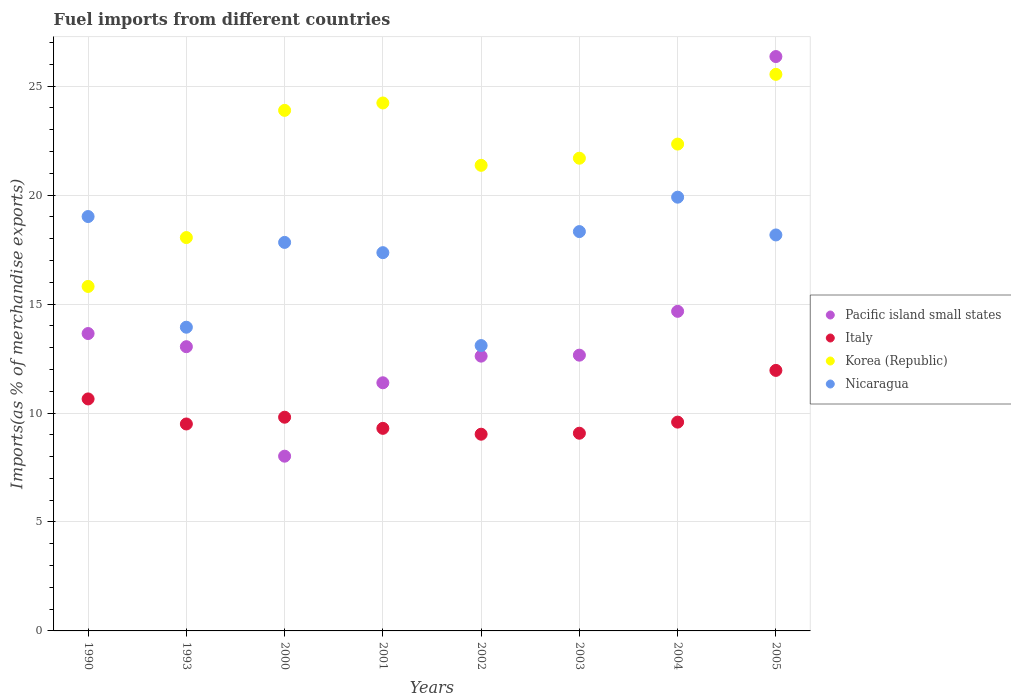How many different coloured dotlines are there?
Ensure brevity in your answer.  4. Is the number of dotlines equal to the number of legend labels?
Give a very brief answer. Yes. What is the percentage of imports to different countries in Korea (Republic) in 2005?
Your answer should be compact. 25.54. Across all years, what is the maximum percentage of imports to different countries in Pacific island small states?
Offer a terse response. 26.36. Across all years, what is the minimum percentage of imports to different countries in Pacific island small states?
Provide a succinct answer. 8.02. In which year was the percentage of imports to different countries in Nicaragua maximum?
Offer a terse response. 2004. What is the total percentage of imports to different countries in Italy in the graph?
Make the answer very short. 78.89. What is the difference between the percentage of imports to different countries in Nicaragua in 1993 and that in 2000?
Provide a succinct answer. -3.89. What is the difference between the percentage of imports to different countries in Nicaragua in 2000 and the percentage of imports to different countries in Italy in 1990?
Keep it short and to the point. 7.18. What is the average percentage of imports to different countries in Korea (Republic) per year?
Keep it short and to the point. 21.62. In the year 2000, what is the difference between the percentage of imports to different countries in Nicaragua and percentage of imports to different countries in Italy?
Ensure brevity in your answer.  8.02. In how many years, is the percentage of imports to different countries in Pacific island small states greater than 15 %?
Make the answer very short. 1. What is the ratio of the percentage of imports to different countries in Italy in 1990 to that in 2002?
Your answer should be very brief. 1.18. Is the difference between the percentage of imports to different countries in Nicaragua in 1993 and 2001 greater than the difference between the percentage of imports to different countries in Italy in 1993 and 2001?
Offer a very short reply. No. What is the difference between the highest and the second highest percentage of imports to different countries in Pacific island small states?
Your answer should be very brief. 11.69. What is the difference between the highest and the lowest percentage of imports to different countries in Nicaragua?
Ensure brevity in your answer.  6.81. In how many years, is the percentage of imports to different countries in Korea (Republic) greater than the average percentage of imports to different countries in Korea (Republic) taken over all years?
Offer a terse response. 5. Is it the case that in every year, the sum of the percentage of imports to different countries in Italy and percentage of imports to different countries in Pacific island small states  is greater than the sum of percentage of imports to different countries in Korea (Republic) and percentage of imports to different countries in Nicaragua?
Offer a terse response. No. Does the percentage of imports to different countries in Pacific island small states monotonically increase over the years?
Provide a succinct answer. No. Is the percentage of imports to different countries in Korea (Republic) strictly greater than the percentage of imports to different countries in Pacific island small states over the years?
Offer a very short reply. No. How many dotlines are there?
Offer a very short reply. 4. How many years are there in the graph?
Your answer should be compact. 8. Are the values on the major ticks of Y-axis written in scientific E-notation?
Your answer should be very brief. No. Does the graph contain grids?
Offer a terse response. Yes. Where does the legend appear in the graph?
Ensure brevity in your answer.  Center right. What is the title of the graph?
Your answer should be very brief. Fuel imports from different countries. What is the label or title of the X-axis?
Offer a very short reply. Years. What is the label or title of the Y-axis?
Keep it short and to the point. Imports(as % of merchandise exports). What is the Imports(as % of merchandise exports) of Pacific island small states in 1990?
Your response must be concise. 13.65. What is the Imports(as % of merchandise exports) in Italy in 1990?
Keep it short and to the point. 10.65. What is the Imports(as % of merchandise exports) in Korea (Republic) in 1990?
Provide a short and direct response. 15.81. What is the Imports(as % of merchandise exports) in Nicaragua in 1990?
Provide a short and direct response. 19.02. What is the Imports(as % of merchandise exports) in Pacific island small states in 1993?
Ensure brevity in your answer.  13.04. What is the Imports(as % of merchandise exports) of Italy in 1993?
Keep it short and to the point. 9.5. What is the Imports(as % of merchandise exports) in Korea (Republic) in 1993?
Give a very brief answer. 18.05. What is the Imports(as % of merchandise exports) of Nicaragua in 1993?
Your answer should be very brief. 13.94. What is the Imports(as % of merchandise exports) of Pacific island small states in 2000?
Provide a short and direct response. 8.02. What is the Imports(as % of merchandise exports) in Italy in 2000?
Offer a terse response. 9.81. What is the Imports(as % of merchandise exports) in Korea (Republic) in 2000?
Make the answer very short. 23.89. What is the Imports(as % of merchandise exports) of Nicaragua in 2000?
Ensure brevity in your answer.  17.83. What is the Imports(as % of merchandise exports) of Pacific island small states in 2001?
Ensure brevity in your answer.  11.39. What is the Imports(as % of merchandise exports) in Italy in 2001?
Provide a short and direct response. 9.3. What is the Imports(as % of merchandise exports) in Korea (Republic) in 2001?
Make the answer very short. 24.23. What is the Imports(as % of merchandise exports) of Nicaragua in 2001?
Ensure brevity in your answer.  17.36. What is the Imports(as % of merchandise exports) of Pacific island small states in 2002?
Your response must be concise. 12.61. What is the Imports(as % of merchandise exports) in Italy in 2002?
Your response must be concise. 9.03. What is the Imports(as % of merchandise exports) in Korea (Republic) in 2002?
Your answer should be compact. 21.37. What is the Imports(as % of merchandise exports) in Nicaragua in 2002?
Keep it short and to the point. 13.1. What is the Imports(as % of merchandise exports) in Pacific island small states in 2003?
Offer a terse response. 12.66. What is the Imports(as % of merchandise exports) in Italy in 2003?
Provide a succinct answer. 9.07. What is the Imports(as % of merchandise exports) of Korea (Republic) in 2003?
Your response must be concise. 21.69. What is the Imports(as % of merchandise exports) in Nicaragua in 2003?
Give a very brief answer. 18.33. What is the Imports(as % of merchandise exports) in Pacific island small states in 2004?
Offer a very short reply. 14.67. What is the Imports(as % of merchandise exports) of Italy in 2004?
Your response must be concise. 9.58. What is the Imports(as % of merchandise exports) of Korea (Republic) in 2004?
Keep it short and to the point. 22.34. What is the Imports(as % of merchandise exports) of Nicaragua in 2004?
Provide a short and direct response. 19.91. What is the Imports(as % of merchandise exports) in Pacific island small states in 2005?
Make the answer very short. 26.36. What is the Imports(as % of merchandise exports) of Italy in 2005?
Keep it short and to the point. 11.96. What is the Imports(as % of merchandise exports) of Korea (Republic) in 2005?
Provide a short and direct response. 25.54. What is the Imports(as % of merchandise exports) of Nicaragua in 2005?
Make the answer very short. 18.17. Across all years, what is the maximum Imports(as % of merchandise exports) in Pacific island small states?
Make the answer very short. 26.36. Across all years, what is the maximum Imports(as % of merchandise exports) of Italy?
Offer a very short reply. 11.96. Across all years, what is the maximum Imports(as % of merchandise exports) of Korea (Republic)?
Ensure brevity in your answer.  25.54. Across all years, what is the maximum Imports(as % of merchandise exports) in Nicaragua?
Provide a succinct answer. 19.91. Across all years, what is the minimum Imports(as % of merchandise exports) of Pacific island small states?
Keep it short and to the point. 8.02. Across all years, what is the minimum Imports(as % of merchandise exports) of Italy?
Make the answer very short. 9.03. Across all years, what is the minimum Imports(as % of merchandise exports) in Korea (Republic)?
Provide a succinct answer. 15.81. Across all years, what is the minimum Imports(as % of merchandise exports) of Nicaragua?
Your answer should be compact. 13.1. What is the total Imports(as % of merchandise exports) of Pacific island small states in the graph?
Your answer should be compact. 112.4. What is the total Imports(as % of merchandise exports) in Italy in the graph?
Keep it short and to the point. 78.89. What is the total Imports(as % of merchandise exports) of Korea (Republic) in the graph?
Ensure brevity in your answer.  172.93. What is the total Imports(as % of merchandise exports) in Nicaragua in the graph?
Keep it short and to the point. 137.65. What is the difference between the Imports(as % of merchandise exports) in Pacific island small states in 1990 and that in 1993?
Provide a succinct answer. 0.6. What is the difference between the Imports(as % of merchandise exports) of Italy in 1990 and that in 1993?
Your response must be concise. 1.15. What is the difference between the Imports(as % of merchandise exports) of Korea (Republic) in 1990 and that in 1993?
Your answer should be very brief. -2.24. What is the difference between the Imports(as % of merchandise exports) in Nicaragua in 1990 and that in 1993?
Offer a terse response. 5.08. What is the difference between the Imports(as % of merchandise exports) of Pacific island small states in 1990 and that in 2000?
Your answer should be very brief. 5.63. What is the difference between the Imports(as % of merchandise exports) of Italy in 1990 and that in 2000?
Offer a very short reply. 0.84. What is the difference between the Imports(as % of merchandise exports) of Korea (Republic) in 1990 and that in 2000?
Make the answer very short. -8.08. What is the difference between the Imports(as % of merchandise exports) of Nicaragua in 1990 and that in 2000?
Offer a terse response. 1.19. What is the difference between the Imports(as % of merchandise exports) of Pacific island small states in 1990 and that in 2001?
Offer a terse response. 2.26. What is the difference between the Imports(as % of merchandise exports) in Italy in 1990 and that in 2001?
Keep it short and to the point. 1.35. What is the difference between the Imports(as % of merchandise exports) in Korea (Republic) in 1990 and that in 2001?
Your answer should be compact. -8.42. What is the difference between the Imports(as % of merchandise exports) of Nicaragua in 1990 and that in 2001?
Give a very brief answer. 1.66. What is the difference between the Imports(as % of merchandise exports) in Pacific island small states in 1990 and that in 2002?
Make the answer very short. 1.04. What is the difference between the Imports(as % of merchandise exports) of Italy in 1990 and that in 2002?
Your answer should be very brief. 1.62. What is the difference between the Imports(as % of merchandise exports) in Korea (Republic) in 1990 and that in 2002?
Make the answer very short. -5.56. What is the difference between the Imports(as % of merchandise exports) of Nicaragua in 1990 and that in 2002?
Your answer should be very brief. 5.92. What is the difference between the Imports(as % of merchandise exports) in Italy in 1990 and that in 2003?
Give a very brief answer. 1.57. What is the difference between the Imports(as % of merchandise exports) of Korea (Republic) in 1990 and that in 2003?
Ensure brevity in your answer.  -5.88. What is the difference between the Imports(as % of merchandise exports) in Nicaragua in 1990 and that in 2003?
Provide a short and direct response. 0.69. What is the difference between the Imports(as % of merchandise exports) of Pacific island small states in 1990 and that in 2004?
Keep it short and to the point. -1.02. What is the difference between the Imports(as % of merchandise exports) of Italy in 1990 and that in 2004?
Keep it short and to the point. 1.06. What is the difference between the Imports(as % of merchandise exports) of Korea (Republic) in 1990 and that in 2004?
Ensure brevity in your answer.  -6.53. What is the difference between the Imports(as % of merchandise exports) in Nicaragua in 1990 and that in 2004?
Keep it short and to the point. -0.89. What is the difference between the Imports(as % of merchandise exports) in Pacific island small states in 1990 and that in 2005?
Give a very brief answer. -12.71. What is the difference between the Imports(as % of merchandise exports) in Italy in 1990 and that in 2005?
Provide a short and direct response. -1.31. What is the difference between the Imports(as % of merchandise exports) of Korea (Republic) in 1990 and that in 2005?
Your answer should be compact. -9.73. What is the difference between the Imports(as % of merchandise exports) of Nicaragua in 1990 and that in 2005?
Make the answer very short. 0.84. What is the difference between the Imports(as % of merchandise exports) of Pacific island small states in 1993 and that in 2000?
Provide a succinct answer. 5.03. What is the difference between the Imports(as % of merchandise exports) in Italy in 1993 and that in 2000?
Offer a very short reply. -0.31. What is the difference between the Imports(as % of merchandise exports) in Korea (Republic) in 1993 and that in 2000?
Provide a succinct answer. -5.84. What is the difference between the Imports(as % of merchandise exports) in Nicaragua in 1993 and that in 2000?
Give a very brief answer. -3.89. What is the difference between the Imports(as % of merchandise exports) of Pacific island small states in 1993 and that in 2001?
Ensure brevity in your answer.  1.66. What is the difference between the Imports(as % of merchandise exports) of Italy in 1993 and that in 2001?
Your answer should be compact. 0.2. What is the difference between the Imports(as % of merchandise exports) in Korea (Republic) in 1993 and that in 2001?
Offer a terse response. -6.18. What is the difference between the Imports(as % of merchandise exports) in Nicaragua in 1993 and that in 2001?
Ensure brevity in your answer.  -3.42. What is the difference between the Imports(as % of merchandise exports) of Pacific island small states in 1993 and that in 2002?
Make the answer very short. 0.43. What is the difference between the Imports(as % of merchandise exports) in Italy in 1993 and that in 2002?
Offer a terse response. 0.47. What is the difference between the Imports(as % of merchandise exports) in Korea (Republic) in 1993 and that in 2002?
Ensure brevity in your answer.  -3.32. What is the difference between the Imports(as % of merchandise exports) in Nicaragua in 1993 and that in 2002?
Offer a very short reply. 0.84. What is the difference between the Imports(as % of merchandise exports) in Pacific island small states in 1993 and that in 2003?
Give a very brief answer. 0.39. What is the difference between the Imports(as % of merchandise exports) of Italy in 1993 and that in 2003?
Ensure brevity in your answer.  0.42. What is the difference between the Imports(as % of merchandise exports) of Korea (Republic) in 1993 and that in 2003?
Give a very brief answer. -3.64. What is the difference between the Imports(as % of merchandise exports) of Nicaragua in 1993 and that in 2003?
Offer a terse response. -4.39. What is the difference between the Imports(as % of merchandise exports) of Pacific island small states in 1993 and that in 2004?
Offer a terse response. -1.62. What is the difference between the Imports(as % of merchandise exports) in Italy in 1993 and that in 2004?
Your response must be concise. -0.09. What is the difference between the Imports(as % of merchandise exports) of Korea (Republic) in 1993 and that in 2004?
Provide a succinct answer. -4.29. What is the difference between the Imports(as % of merchandise exports) in Nicaragua in 1993 and that in 2004?
Your answer should be very brief. -5.97. What is the difference between the Imports(as % of merchandise exports) of Pacific island small states in 1993 and that in 2005?
Ensure brevity in your answer.  -13.32. What is the difference between the Imports(as % of merchandise exports) in Italy in 1993 and that in 2005?
Your response must be concise. -2.46. What is the difference between the Imports(as % of merchandise exports) of Korea (Republic) in 1993 and that in 2005?
Ensure brevity in your answer.  -7.49. What is the difference between the Imports(as % of merchandise exports) of Nicaragua in 1993 and that in 2005?
Ensure brevity in your answer.  -4.24. What is the difference between the Imports(as % of merchandise exports) of Pacific island small states in 2000 and that in 2001?
Ensure brevity in your answer.  -3.37. What is the difference between the Imports(as % of merchandise exports) in Italy in 2000 and that in 2001?
Provide a succinct answer. 0.51. What is the difference between the Imports(as % of merchandise exports) of Korea (Republic) in 2000 and that in 2001?
Provide a succinct answer. -0.34. What is the difference between the Imports(as % of merchandise exports) of Nicaragua in 2000 and that in 2001?
Your answer should be compact. 0.47. What is the difference between the Imports(as % of merchandise exports) in Pacific island small states in 2000 and that in 2002?
Your response must be concise. -4.59. What is the difference between the Imports(as % of merchandise exports) of Italy in 2000 and that in 2002?
Offer a terse response. 0.78. What is the difference between the Imports(as % of merchandise exports) of Korea (Republic) in 2000 and that in 2002?
Offer a very short reply. 2.52. What is the difference between the Imports(as % of merchandise exports) in Nicaragua in 2000 and that in 2002?
Your answer should be compact. 4.73. What is the difference between the Imports(as % of merchandise exports) of Pacific island small states in 2000 and that in 2003?
Make the answer very short. -4.64. What is the difference between the Imports(as % of merchandise exports) of Italy in 2000 and that in 2003?
Your response must be concise. 0.74. What is the difference between the Imports(as % of merchandise exports) in Korea (Republic) in 2000 and that in 2003?
Your answer should be compact. 2.2. What is the difference between the Imports(as % of merchandise exports) in Nicaragua in 2000 and that in 2003?
Give a very brief answer. -0.5. What is the difference between the Imports(as % of merchandise exports) in Pacific island small states in 2000 and that in 2004?
Provide a short and direct response. -6.65. What is the difference between the Imports(as % of merchandise exports) in Italy in 2000 and that in 2004?
Provide a succinct answer. 0.23. What is the difference between the Imports(as % of merchandise exports) of Korea (Republic) in 2000 and that in 2004?
Ensure brevity in your answer.  1.55. What is the difference between the Imports(as % of merchandise exports) in Nicaragua in 2000 and that in 2004?
Your response must be concise. -2.08. What is the difference between the Imports(as % of merchandise exports) in Pacific island small states in 2000 and that in 2005?
Offer a very short reply. -18.34. What is the difference between the Imports(as % of merchandise exports) of Italy in 2000 and that in 2005?
Your answer should be compact. -2.15. What is the difference between the Imports(as % of merchandise exports) in Korea (Republic) in 2000 and that in 2005?
Ensure brevity in your answer.  -1.65. What is the difference between the Imports(as % of merchandise exports) of Nicaragua in 2000 and that in 2005?
Provide a succinct answer. -0.34. What is the difference between the Imports(as % of merchandise exports) in Pacific island small states in 2001 and that in 2002?
Your answer should be compact. -1.22. What is the difference between the Imports(as % of merchandise exports) in Italy in 2001 and that in 2002?
Make the answer very short. 0.27. What is the difference between the Imports(as % of merchandise exports) in Korea (Republic) in 2001 and that in 2002?
Your answer should be very brief. 2.86. What is the difference between the Imports(as % of merchandise exports) in Nicaragua in 2001 and that in 2002?
Give a very brief answer. 4.26. What is the difference between the Imports(as % of merchandise exports) in Pacific island small states in 2001 and that in 2003?
Provide a short and direct response. -1.27. What is the difference between the Imports(as % of merchandise exports) in Italy in 2001 and that in 2003?
Offer a very short reply. 0.22. What is the difference between the Imports(as % of merchandise exports) of Korea (Republic) in 2001 and that in 2003?
Offer a terse response. 2.54. What is the difference between the Imports(as % of merchandise exports) of Nicaragua in 2001 and that in 2003?
Provide a short and direct response. -0.97. What is the difference between the Imports(as % of merchandise exports) in Pacific island small states in 2001 and that in 2004?
Your answer should be very brief. -3.28. What is the difference between the Imports(as % of merchandise exports) in Italy in 2001 and that in 2004?
Give a very brief answer. -0.29. What is the difference between the Imports(as % of merchandise exports) in Korea (Republic) in 2001 and that in 2004?
Keep it short and to the point. 1.89. What is the difference between the Imports(as % of merchandise exports) in Nicaragua in 2001 and that in 2004?
Ensure brevity in your answer.  -2.55. What is the difference between the Imports(as % of merchandise exports) of Pacific island small states in 2001 and that in 2005?
Keep it short and to the point. -14.97. What is the difference between the Imports(as % of merchandise exports) in Italy in 2001 and that in 2005?
Keep it short and to the point. -2.66. What is the difference between the Imports(as % of merchandise exports) in Korea (Republic) in 2001 and that in 2005?
Provide a succinct answer. -1.31. What is the difference between the Imports(as % of merchandise exports) in Nicaragua in 2001 and that in 2005?
Provide a short and direct response. -0.81. What is the difference between the Imports(as % of merchandise exports) in Pacific island small states in 2002 and that in 2003?
Give a very brief answer. -0.04. What is the difference between the Imports(as % of merchandise exports) of Italy in 2002 and that in 2003?
Give a very brief answer. -0.04. What is the difference between the Imports(as % of merchandise exports) in Korea (Republic) in 2002 and that in 2003?
Keep it short and to the point. -0.33. What is the difference between the Imports(as % of merchandise exports) in Nicaragua in 2002 and that in 2003?
Provide a short and direct response. -5.23. What is the difference between the Imports(as % of merchandise exports) in Pacific island small states in 2002 and that in 2004?
Provide a succinct answer. -2.06. What is the difference between the Imports(as % of merchandise exports) of Italy in 2002 and that in 2004?
Make the answer very short. -0.55. What is the difference between the Imports(as % of merchandise exports) of Korea (Republic) in 2002 and that in 2004?
Your response must be concise. -0.97. What is the difference between the Imports(as % of merchandise exports) in Nicaragua in 2002 and that in 2004?
Offer a terse response. -6.81. What is the difference between the Imports(as % of merchandise exports) of Pacific island small states in 2002 and that in 2005?
Your response must be concise. -13.75. What is the difference between the Imports(as % of merchandise exports) of Italy in 2002 and that in 2005?
Ensure brevity in your answer.  -2.93. What is the difference between the Imports(as % of merchandise exports) in Korea (Republic) in 2002 and that in 2005?
Your answer should be compact. -4.17. What is the difference between the Imports(as % of merchandise exports) of Nicaragua in 2002 and that in 2005?
Make the answer very short. -5.08. What is the difference between the Imports(as % of merchandise exports) in Pacific island small states in 2003 and that in 2004?
Your response must be concise. -2.01. What is the difference between the Imports(as % of merchandise exports) in Italy in 2003 and that in 2004?
Offer a terse response. -0.51. What is the difference between the Imports(as % of merchandise exports) of Korea (Republic) in 2003 and that in 2004?
Offer a very short reply. -0.65. What is the difference between the Imports(as % of merchandise exports) in Nicaragua in 2003 and that in 2004?
Offer a very short reply. -1.58. What is the difference between the Imports(as % of merchandise exports) of Pacific island small states in 2003 and that in 2005?
Provide a short and direct response. -13.7. What is the difference between the Imports(as % of merchandise exports) in Italy in 2003 and that in 2005?
Make the answer very short. -2.88. What is the difference between the Imports(as % of merchandise exports) of Korea (Republic) in 2003 and that in 2005?
Make the answer very short. -3.85. What is the difference between the Imports(as % of merchandise exports) of Nicaragua in 2003 and that in 2005?
Your answer should be compact. 0.15. What is the difference between the Imports(as % of merchandise exports) in Pacific island small states in 2004 and that in 2005?
Ensure brevity in your answer.  -11.69. What is the difference between the Imports(as % of merchandise exports) of Italy in 2004 and that in 2005?
Your response must be concise. -2.37. What is the difference between the Imports(as % of merchandise exports) of Korea (Republic) in 2004 and that in 2005?
Offer a terse response. -3.2. What is the difference between the Imports(as % of merchandise exports) in Nicaragua in 2004 and that in 2005?
Your answer should be very brief. 1.73. What is the difference between the Imports(as % of merchandise exports) in Pacific island small states in 1990 and the Imports(as % of merchandise exports) in Italy in 1993?
Make the answer very short. 4.15. What is the difference between the Imports(as % of merchandise exports) in Pacific island small states in 1990 and the Imports(as % of merchandise exports) in Korea (Republic) in 1993?
Your answer should be very brief. -4.4. What is the difference between the Imports(as % of merchandise exports) in Pacific island small states in 1990 and the Imports(as % of merchandise exports) in Nicaragua in 1993?
Keep it short and to the point. -0.29. What is the difference between the Imports(as % of merchandise exports) of Italy in 1990 and the Imports(as % of merchandise exports) of Korea (Republic) in 1993?
Your response must be concise. -7.41. What is the difference between the Imports(as % of merchandise exports) of Italy in 1990 and the Imports(as % of merchandise exports) of Nicaragua in 1993?
Provide a short and direct response. -3.29. What is the difference between the Imports(as % of merchandise exports) of Korea (Republic) in 1990 and the Imports(as % of merchandise exports) of Nicaragua in 1993?
Provide a short and direct response. 1.87. What is the difference between the Imports(as % of merchandise exports) in Pacific island small states in 1990 and the Imports(as % of merchandise exports) in Italy in 2000?
Offer a very short reply. 3.84. What is the difference between the Imports(as % of merchandise exports) of Pacific island small states in 1990 and the Imports(as % of merchandise exports) of Korea (Republic) in 2000?
Offer a very short reply. -10.24. What is the difference between the Imports(as % of merchandise exports) in Pacific island small states in 1990 and the Imports(as % of merchandise exports) in Nicaragua in 2000?
Keep it short and to the point. -4.18. What is the difference between the Imports(as % of merchandise exports) in Italy in 1990 and the Imports(as % of merchandise exports) in Korea (Republic) in 2000?
Offer a very short reply. -13.24. What is the difference between the Imports(as % of merchandise exports) in Italy in 1990 and the Imports(as % of merchandise exports) in Nicaragua in 2000?
Provide a succinct answer. -7.18. What is the difference between the Imports(as % of merchandise exports) of Korea (Republic) in 1990 and the Imports(as % of merchandise exports) of Nicaragua in 2000?
Your answer should be compact. -2.02. What is the difference between the Imports(as % of merchandise exports) in Pacific island small states in 1990 and the Imports(as % of merchandise exports) in Italy in 2001?
Make the answer very short. 4.35. What is the difference between the Imports(as % of merchandise exports) of Pacific island small states in 1990 and the Imports(as % of merchandise exports) of Korea (Republic) in 2001?
Your answer should be compact. -10.58. What is the difference between the Imports(as % of merchandise exports) in Pacific island small states in 1990 and the Imports(as % of merchandise exports) in Nicaragua in 2001?
Your answer should be very brief. -3.71. What is the difference between the Imports(as % of merchandise exports) in Italy in 1990 and the Imports(as % of merchandise exports) in Korea (Republic) in 2001?
Provide a short and direct response. -13.58. What is the difference between the Imports(as % of merchandise exports) in Italy in 1990 and the Imports(as % of merchandise exports) in Nicaragua in 2001?
Provide a succinct answer. -6.71. What is the difference between the Imports(as % of merchandise exports) of Korea (Republic) in 1990 and the Imports(as % of merchandise exports) of Nicaragua in 2001?
Your response must be concise. -1.55. What is the difference between the Imports(as % of merchandise exports) of Pacific island small states in 1990 and the Imports(as % of merchandise exports) of Italy in 2002?
Give a very brief answer. 4.62. What is the difference between the Imports(as % of merchandise exports) in Pacific island small states in 1990 and the Imports(as % of merchandise exports) in Korea (Republic) in 2002?
Ensure brevity in your answer.  -7.72. What is the difference between the Imports(as % of merchandise exports) of Pacific island small states in 1990 and the Imports(as % of merchandise exports) of Nicaragua in 2002?
Ensure brevity in your answer.  0.55. What is the difference between the Imports(as % of merchandise exports) in Italy in 1990 and the Imports(as % of merchandise exports) in Korea (Republic) in 2002?
Offer a very short reply. -10.72. What is the difference between the Imports(as % of merchandise exports) of Italy in 1990 and the Imports(as % of merchandise exports) of Nicaragua in 2002?
Offer a terse response. -2.45. What is the difference between the Imports(as % of merchandise exports) of Korea (Republic) in 1990 and the Imports(as % of merchandise exports) of Nicaragua in 2002?
Your response must be concise. 2.71. What is the difference between the Imports(as % of merchandise exports) in Pacific island small states in 1990 and the Imports(as % of merchandise exports) in Italy in 2003?
Give a very brief answer. 4.58. What is the difference between the Imports(as % of merchandise exports) in Pacific island small states in 1990 and the Imports(as % of merchandise exports) in Korea (Republic) in 2003?
Offer a very short reply. -8.05. What is the difference between the Imports(as % of merchandise exports) in Pacific island small states in 1990 and the Imports(as % of merchandise exports) in Nicaragua in 2003?
Offer a very short reply. -4.68. What is the difference between the Imports(as % of merchandise exports) in Italy in 1990 and the Imports(as % of merchandise exports) in Korea (Republic) in 2003?
Offer a very short reply. -11.05. What is the difference between the Imports(as % of merchandise exports) of Italy in 1990 and the Imports(as % of merchandise exports) of Nicaragua in 2003?
Make the answer very short. -7.68. What is the difference between the Imports(as % of merchandise exports) in Korea (Republic) in 1990 and the Imports(as % of merchandise exports) in Nicaragua in 2003?
Give a very brief answer. -2.52. What is the difference between the Imports(as % of merchandise exports) of Pacific island small states in 1990 and the Imports(as % of merchandise exports) of Italy in 2004?
Make the answer very short. 4.07. What is the difference between the Imports(as % of merchandise exports) in Pacific island small states in 1990 and the Imports(as % of merchandise exports) in Korea (Republic) in 2004?
Your answer should be very brief. -8.69. What is the difference between the Imports(as % of merchandise exports) of Pacific island small states in 1990 and the Imports(as % of merchandise exports) of Nicaragua in 2004?
Keep it short and to the point. -6.26. What is the difference between the Imports(as % of merchandise exports) in Italy in 1990 and the Imports(as % of merchandise exports) in Korea (Republic) in 2004?
Make the answer very short. -11.7. What is the difference between the Imports(as % of merchandise exports) of Italy in 1990 and the Imports(as % of merchandise exports) of Nicaragua in 2004?
Your response must be concise. -9.26. What is the difference between the Imports(as % of merchandise exports) of Korea (Republic) in 1990 and the Imports(as % of merchandise exports) of Nicaragua in 2004?
Your answer should be very brief. -4.1. What is the difference between the Imports(as % of merchandise exports) of Pacific island small states in 1990 and the Imports(as % of merchandise exports) of Italy in 2005?
Give a very brief answer. 1.69. What is the difference between the Imports(as % of merchandise exports) of Pacific island small states in 1990 and the Imports(as % of merchandise exports) of Korea (Republic) in 2005?
Provide a succinct answer. -11.89. What is the difference between the Imports(as % of merchandise exports) in Pacific island small states in 1990 and the Imports(as % of merchandise exports) in Nicaragua in 2005?
Give a very brief answer. -4.53. What is the difference between the Imports(as % of merchandise exports) in Italy in 1990 and the Imports(as % of merchandise exports) in Korea (Republic) in 2005?
Provide a short and direct response. -14.9. What is the difference between the Imports(as % of merchandise exports) in Italy in 1990 and the Imports(as % of merchandise exports) in Nicaragua in 2005?
Your response must be concise. -7.53. What is the difference between the Imports(as % of merchandise exports) in Korea (Republic) in 1990 and the Imports(as % of merchandise exports) in Nicaragua in 2005?
Your answer should be very brief. -2.36. What is the difference between the Imports(as % of merchandise exports) of Pacific island small states in 1993 and the Imports(as % of merchandise exports) of Italy in 2000?
Provide a short and direct response. 3.24. What is the difference between the Imports(as % of merchandise exports) in Pacific island small states in 1993 and the Imports(as % of merchandise exports) in Korea (Republic) in 2000?
Make the answer very short. -10.85. What is the difference between the Imports(as % of merchandise exports) in Pacific island small states in 1993 and the Imports(as % of merchandise exports) in Nicaragua in 2000?
Give a very brief answer. -4.79. What is the difference between the Imports(as % of merchandise exports) of Italy in 1993 and the Imports(as % of merchandise exports) of Korea (Republic) in 2000?
Your answer should be very brief. -14.39. What is the difference between the Imports(as % of merchandise exports) of Italy in 1993 and the Imports(as % of merchandise exports) of Nicaragua in 2000?
Provide a succinct answer. -8.33. What is the difference between the Imports(as % of merchandise exports) of Korea (Republic) in 1993 and the Imports(as % of merchandise exports) of Nicaragua in 2000?
Ensure brevity in your answer.  0.22. What is the difference between the Imports(as % of merchandise exports) of Pacific island small states in 1993 and the Imports(as % of merchandise exports) of Italy in 2001?
Make the answer very short. 3.75. What is the difference between the Imports(as % of merchandise exports) in Pacific island small states in 1993 and the Imports(as % of merchandise exports) in Korea (Republic) in 2001?
Offer a terse response. -11.19. What is the difference between the Imports(as % of merchandise exports) in Pacific island small states in 1993 and the Imports(as % of merchandise exports) in Nicaragua in 2001?
Your answer should be very brief. -4.32. What is the difference between the Imports(as % of merchandise exports) in Italy in 1993 and the Imports(as % of merchandise exports) in Korea (Republic) in 2001?
Offer a very short reply. -14.73. What is the difference between the Imports(as % of merchandise exports) of Italy in 1993 and the Imports(as % of merchandise exports) of Nicaragua in 2001?
Offer a terse response. -7.86. What is the difference between the Imports(as % of merchandise exports) in Korea (Republic) in 1993 and the Imports(as % of merchandise exports) in Nicaragua in 2001?
Offer a very short reply. 0.69. What is the difference between the Imports(as % of merchandise exports) in Pacific island small states in 1993 and the Imports(as % of merchandise exports) in Italy in 2002?
Your answer should be compact. 4.02. What is the difference between the Imports(as % of merchandise exports) in Pacific island small states in 1993 and the Imports(as % of merchandise exports) in Korea (Republic) in 2002?
Your response must be concise. -8.32. What is the difference between the Imports(as % of merchandise exports) of Pacific island small states in 1993 and the Imports(as % of merchandise exports) of Nicaragua in 2002?
Provide a succinct answer. -0.05. What is the difference between the Imports(as % of merchandise exports) in Italy in 1993 and the Imports(as % of merchandise exports) in Korea (Republic) in 2002?
Offer a terse response. -11.87. What is the difference between the Imports(as % of merchandise exports) in Italy in 1993 and the Imports(as % of merchandise exports) in Nicaragua in 2002?
Make the answer very short. -3.6. What is the difference between the Imports(as % of merchandise exports) of Korea (Republic) in 1993 and the Imports(as % of merchandise exports) of Nicaragua in 2002?
Your answer should be very brief. 4.96. What is the difference between the Imports(as % of merchandise exports) of Pacific island small states in 1993 and the Imports(as % of merchandise exports) of Italy in 2003?
Offer a very short reply. 3.97. What is the difference between the Imports(as % of merchandise exports) in Pacific island small states in 1993 and the Imports(as % of merchandise exports) in Korea (Republic) in 2003?
Your answer should be compact. -8.65. What is the difference between the Imports(as % of merchandise exports) in Pacific island small states in 1993 and the Imports(as % of merchandise exports) in Nicaragua in 2003?
Provide a succinct answer. -5.28. What is the difference between the Imports(as % of merchandise exports) of Italy in 1993 and the Imports(as % of merchandise exports) of Korea (Republic) in 2003?
Make the answer very short. -12.2. What is the difference between the Imports(as % of merchandise exports) of Italy in 1993 and the Imports(as % of merchandise exports) of Nicaragua in 2003?
Your response must be concise. -8.83. What is the difference between the Imports(as % of merchandise exports) of Korea (Republic) in 1993 and the Imports(as % of merchandise exports) of Nicaragua in 2003?
Make the answer very short. -0.27. What is the difference between the Imports(as % of merchandise exports) of Pacific island small states in 1993 and the Imports(as % of merchandise exports) of Italy in 2004?
Give a very brief answer. 3.46. What is the difference between the Imports(as % of merchandise exports) in Pacific island small states in 1993 and the Imports(as % of merchandise exports) in Korea (Republic) in 2004?
Your answer should be very brief. -9.3. What is the difference between the Imports(as % of merchandise exports) in Pacific island small states in 1993 and the Imports(as % of merchandise exports) in Nicaragua in 2004?
Your response must be concise. -6.86. What is the difference between the Imports(as % of merchandise exports) of Italy in 1993 and the Imports(as % of merchandise exports) of Korea (Republic) in 2004?
Your answer should be compact. -12.85. What is the difference between the Imports(as % of merchandise exports) of Italy in 1993 and the Imports(as % of merchandise exports) of Nicaragua in 2004?
Keep it short and to the point. -10.41. What is the difference between the Imports(as % of merchandise exports) of Korea (Republic) in 1993 and the Imports(as % of merchandise exports) of Nicaragua in 2004?
Provide a succinct answer. -1.85. What is the difference between the Imports(as % of merchandise exports) in Pacific island small states in 1993 and the Imports(as % of merchandise exports) in Italy in 2005?
Your answer should be compact. 1.09. What is the difference between the Imports(as % of merchandise exports) of Pacific island small states in 1993 and the Imports(as % of merchandise exports) of Korea (Republic) in 2005?
Provide a short and direct response. -12.5. What is the difference between the Imports(as % of merchandise exports) of Pacific island small states in 1993 and the Imports(as % of merchandise exports) of Nicaragua in 2005?
Provide a succinct answer. -5.13. What is the difference between the Imports(as % of merchandise exports) in Italy in 1993 and the Imports(as % of merchandise exports) in Korea (Republic) in 2005?
Provide a succinct answer. -16.05. What is the difference between the Imports(as % of merchandise exports) of Italy in 1993 and the Imports(as % of merchandise exports) of Nicaragua in 2005?
Ensure brevity in your answer.  -8.68. What is the difference between the Imports(as % of merchandise exports) in Korea (Republic) in 1993 and the Imports(as % of merchandise exports) in Nicaragua in 2005?
Make the answer very short. -0.12. What is the difference between the Imports(as % of merchandise exports) in Pacific island small states in 2000 and the Imports(as % of merchandise exports) in Italy in 2001?
Offer a terse response. -1.28. What is the difference between the Imports(as % of merchandise exports) in Pacific island small states in 2000 and the Imports(as % of merchandise exports) in Korea (Republic) in 2001?
Ensure brevity in your answer.  -16.21. What is the difference between the Imports(as % of merchandise exports) of Pacific island small states in 2000 and the Imports(as % of merchandise exports) of Nicaragua in 2001?
Provide a succinct answer. -9.34. What is the difference between the Imports(as % of merchandise exports) of Italy in 2000 and the Imports(as % of merchandise exports) of Korea (Republic) in 2001?
Your response must be concise. -14.42. What is the difference between the Imports(as % of merchandise exports) of Italy in 2000 and the Imports(as % of merchandise exports) of Nicaragua in 2001?
Your answer should be very brief. -7.55. What is the difference between the Imports(as % of merchandise exports) in Korea (Republic) in 2000 and the Imports(as % of merchandise exports) in Nicaragua in 2001?
Ensure brevity in your answer.  6.53. What is the difference between the Imports(as % of merchandise exports) in Pacific island small states in 2000 and the Imports(as % of merchandise exports) in Italy in 2002?
Offer a very short reply. -1.01. What is the difference between the Imports(as % of merchandise exports) in Pacific island small states in 2000 and the Imports(as % of merchandise exports) in Korea (Republic) in 2002?
Keep it short and to the point. -13.35. What is the difference between the Imports(as % of merchandise exports) in Pacific island small states in 2000 and the Imports(as % of merchandise exports) in Nicaragua in 2002?
Offer a terse response. -5.08. What is the difference between the Imports(as % of merchandise exports) in Italy in 2000 and the Imports(as % of merchandise exports) in Korea (Republic) in 2002?
Your response must be concise. -11.56. What is the difference between the Imports(as % of merchandise exports) in Italy in 2000 and the Imports(as % of merchandise exports) in Nicaragua in 2002?
Provide a succinct answer. -3.29. What is the difference between the Imports(as % of merchandise exports) of Korea (Republic) in 2000 and the Imports(as % of merchandise exports) of Nicaragua in 2002?
Offer a very short reply. 10.79. What is the difference between the Imports(as % of merchandise exports) in Pacific island small states in 2000 and the Imports(as % of merchandise exports) in Italy in 2003?
Provide a succinct answer. -1.05. What is the difference between the Imports(as % of merchandise exports) in Pacific island small states in 2000 and the Imports(as % of merchandise exports) in Korea (Republic) in 2003?
Provide a succinct answer. -13.68. What is the difference between the Imports(as % of merchandise exports) in Pacific island small states in 2000 and the Imports(as % of merchandise exports) in Nicaragua in 2003?
Offer a terse response. -10.31. What is the difference between the Imports(as % of merchandise exports) of Italy in 2000 and the Imports(as % of merchandise exports) of Korea (Republic) in 2003?
Your answer should be very brief. -11.89. What is the difference between the Imports(as % of merchandise exports) of Italy in 2000 and the Imports(as % of merchandise exports) of Nicaragua in 2003?
Make the answer very short. -8.52. What is the difference between the Imports(as % of merchandise exports) in Korea (Republic) in 2000 and the Imports(as % of merchandise exports) in Nicaragua in 2003?
Your answer should be very brief. 5.56. What is the difference between the Imports(as % of merchandise exports) of Pacific island small states in 2000 and the Imports(as % of merchandise exports) of Italy in 2004?
Give a very brief answer. -1.56. What is the difference between the Imports(as % of merchandise exports) in Pacific island small states in 2000 and the Imports(as % of merchandise exports) in Korea (Republic) in 2004?
Your response must be concise. -14.32. What is the difference between the Imports(as % of merchandise exports) in Pacific island small states in 2000 and the Imports(as % of merchandise exports) in Nicaragua in 2004?
Your answer should be very brief. -11.89. What is the difference between the Imports(as % of merchandise exports) in Italy in 2000 and the Imports(as % of merchandise exports) in Korea (Republic) in 2004?
Provide a short and direct response. -12.54. What is the difference between the Imports(as % of merchandise exports) of Italy in 2000 and the Imports(as % of merchandise exports) of Nicaragua in 2004?
Your answer should be compact. -10.1. What is the difference between the Imports(as % of merchandise exports) of Korea (Republic) in 2000 and the Imports(as % of merchandise exports) of Nicaragua in 2004?
Your answer should be compact. 3.98. What is the difference between the Imports(as % of merchandise exports) of Pacific island small states in 2000 and the Imports(as % of merchandise exports) of Italy in 2005?
Provide a short and direct response. -3.94. What is the difference between the Imports(as % of merchandise exports) of Pacific island small states in 2000 and the Imports(as % of merchandise exports) of Korea (Republic) in 2005?
Make the answer very short. -17.52. What is the difference between the Imports(as % of merchandise exports) in Pacific island small states in 2000 and the Imports(as % of merchandise exports) in Nicaragua in 2005?
Keep it short and to the point. -10.15. What is the difference between the Imports(as % of merchandise exports) in Italy in 2000 and the Imports(as % of merchandise exports) in Korea (Republic) in 2005?
Provide a short and direct response. -15.74. What is the difference between the Imports(as % of merchandise exports) in Italy in 2000 and the Imports(as % of merchandise exports) in Nicaragua in 2005?
Your answer should be very brief. -8.37. What is the difference between the Imports(as % of merchandise exports) of Korea (Republic) in 2000 and the Imports(as % of merchandise exports) of Nicaragua in 2005?
Provide a succinct answer. 5.72. What is the difference between the Imports(as % of merchandise exports) of Pacific island small states in 2001 and the Imports(as % of merchandise exports) of Italy in 2002?
Your answer should be very brief. 2.36. What is the difference between the Imports(as % of merchandise exports) in Pacific island small states in 2001 and the Imports(as % of merchandise exports) in Korea (Republic) in 2002?
Offer a very short reply. -9.98. What is the difference between the Imports(as % of merchandise exports) of Pacific island small states in 2001 and the Imports(as % of merchandise exports) of Nicaragua in 2002?
Keep it short and to the point. -1.71. What is the difference between the Imports(as % of merchandise exports) of Italy in 2001 and the Imports(as % of merchandise exports) of Korea (Republic) in 2002?
Your answer should be very brief. -12.07. What is the difference between the Imports(as % of merchandise exports) of Italy in 2001 and the Imports(as % of merchandise exports) of Nicaragua in 2002?
Make the answer very short. -3.8. What is the difference between the Imports(as % of merchandise exports) of Korea (Republic) in 2001 and the Imports(as % of merchandise exports) of Nicaragua in 2002?
Provide a succinct answer. 11.13. What is the difference between the Imports(as % of merchandise exports) of Pacific island small states in 2001 and the Imports(as % of merchandise exports) of Italy in 2003?
Give a very brief answer. 2.32. What is the difference between the Imports(as % of merchandise exports) of Pacific island small states in 2001 and the Imports(as % of merchandise exports) of Korea (Republic) in 2003?
Keep it short and to the point. -10.31. What is the difference between the Imports(as % of merchandise exports) in Pacific island small states in 2001 and the Imports(as % of merchandise exports) in Nicaragua in 2003?
Your answer should be very brief. -6.94. What is the difference between the Imports(as % of merchandise exports) of Italy in 2001 and the Imports(as % of merchandise exports) of Korea (Republic) in 2003?
Make the answer very short. -12.4. What is the difference between the Imports(as % of merchandise exports) in Italy in 2001 and the Imports(as % of merchandise exports) in Nicaragua in 2003?
Your answer should be compact. -9.03. What is the difference between the Imports(as % of merchandise exports) of Korea (Republic) in 2001 and the Imports(as % of merchandise exports) of Nicaragua in 2003?
Give a very brief answer. 5.9. What is the difference between the Imports(as % of merchandise exports) of Pacific island small states in 2001 and the Imports(as % of merchandise exports) of Italy in 2004?
Offer a very short reply. 1.81. What is the difference between the Imports(as % of merchandise exports) in Pacific island small states in 2001 and the Imports(as % of merchandise exports) in Korea (Republic) in 2004?
Your response must be concise. -10.95. What is the difference between the Imports(as % of merchandise exports) in Pacific island small states in 2001 and the Imports(as % of merchandise exports) in Nicaragua in 2004?
Give a very brief answer. -8.52. What is the difference between the Imports(as % of merchandise exports) in Italy in 2001 and the Imports(as % of merchandise exports) in Korea (Republic) in 2004?
Provide a short and direct response. -13.05. What is the difference between the Imports(as % of merchandise exports) in Italy in 2001 and the Imports(as % of merchandise exports) in Nicaragua in 2004?
Offer a terse response. -10.61. What is the difference between the Imports(as % of merchandise exports) in Korea (Republic) in 2001 and the Imports(as % of merchandise exports) in Nicaragua in 2004?
Provide a short and direct response. 4.32. What is the difference between the Imports(as % of merchandise exports) of Pacific island small states in 2001 and the Imports(as % of merchandise exports) of Italy in 2005?
Provide a short and direct response. -0.57. What is the difference between the Imports(as % of merchandise exports) in Pacific island small states in 2001 and the Imports(as % of merchandise exports) in Korea (Republic) in 2005?
Offer a terse response. -14.15. What is the difference between the Imports(as % of merchandise exports) in Pacific island small states in 2001 and the Imports(as % of merchandise exports) in Nicaragua in 2005?
Make the answer very short. -6.78. What is the difference between the Imports(as % of merchandise exports) in Italy in 2001 and the Imports(as % of merchandise exports) in Korea (Republic) in 2005?
Give a very brief answer. -16.25. What is the difference between the Imports(as % of merchandise exports) in Italy in 2001 and the Imports(as % of merchandise exports) in Nicaragua in 2005?
Keep it short and to the point. -8.88. What is the difference between the Imports(as % of merchandise exports) in Korea (Republic) in 2001 and the Imports(as % of merchandise exports) in Nicaragua in 2005?
Your answer should be compact. 6.06. What is the difference between the Imports(as % of merchandise exports) in Pacific island small states in 2002 and the Imports(as % of merchandise exports) in Italy in 2003?
Offer a very short reply. 3.54. What is the difference between the Imports(as % of merchandise exports) of Pacific island small states in 2002 and the Imports(as % of merchandise exports) of Korea (Republic) in 2003?
Offer a terse response. -9.08. What is the difference between the Imports(as % of merchandise exports) of Pacific island small states in 2002 and the Imports(as % of merchandise exports) of Nicaragua in 2003?
Make the answer very short. -5.72. What is the difference between the Imports(as % of merchandise exports) in Italy in 2002 and the Imports(as % of merchandise exports) in Korea (Republic) in 2003?
Keep it short and to the point. -12.67. What is the difference between the Imports(as % of merchandise exports) of Italy in 2002 and the Imports(as % of merchandise exports) of Nicaragua in 2003?
Keep it short and to the point. -9.3. What is the difference between the Imports(as % of merchandise exports) in Korea (Republic) in 2002 and the Imports(as % of merchandise exports) in Nicaragua in 2003?
Your response must be concise. 3.04. What is the difference between the Imports(as % of merchandise exports) in Pacific island small states in 2002 and the Imports(as % of merchandise exports) in Italy in 2004?
Provide a succinct answer. 3.03. What is the difference between the Imports(as % of merchandise exports) of Pacific island small states in 2002 and the Imports(as % of merchandise exports) of Korea (Republic) in 2004?
Your answer should be compact. -9.73. What is the difference between the Imports(as % of merchandise exports) in Pacific island small states in 2002 and the Imports(as % of merchandise exports) in Nicaragua in 2004?
Offer a very short reply. -7.3. What is the difference between the Imports(as % of merchandise exports) in Italy in 2002 and the Imports(as % of merchandise exports) in Korea (Republic) in 2004?
Give a very brief answer. -13.32. What is the difference between the Imports(as % of merchandise exports) in Italy in 2002 and the Imports(as % of merchandise exports) in Nicaragua in 2004?
Your answer should be compact. -10.88. What is the difference between the Imports(as % of merchandise exports) in Korea (Republic) in 2002 and the Imports(as % of merchandise exports) in Nicaragua in 2004?
Offer a very short reply. 1.46. What is the difference between the Imports(as % of merchandise exports) of Pacific island small states in 2002 and the Imports(as % of merchandise exports) of Italy in 2005?
Your answer should be compact. 0.65. What is the difference between the Imports(as % of merchandise exports) of Pacific island small states in 2002 and the Imports(as % of merchandise exports) of Korea (Republic) in 2005?
Offer a terse response. -12.93. What is the difference between the Imports(as % of merchandise exports) of Pacific island small states in 2002 and the Imports(as % of merchandise exports) of Nicaragua in 2005?
Ensure brevity in your answer.  -5.56. What is the difference between the Imports(as % of merchandise exports) in Italy in 2002 and the Imports(as % of merchandise exports) in Korea (Republic) in 2005?
Provide a short and direct response. -16.52. What is the difference between the Imports(as % of merchandise exports) of Italy in 2002 and the Imports(as % of merchandise exports) of Nicaragua in 2005?
Your answer should be very brief. -9.15. What is the difference between the Imports(as % of merchandise exports) of Korea (Republic) in 2002 and the Imports(as % of merchandise exports) of Nicaragua in 2005?
Your answer should be compact. 3.2. What is the difference between the Imports(as % of merchandise exports) in Pacific island small states in 2003 and the Imports(as % of merchandise exports) in Italy in 2004?
Keep it short and to the point. 3.07. What is the difference between the Imports(as % of merchandise exports) of Pacific island small states in 2003 and the Imports(as % of merchandise exports) of Korea (Republic) in 2004?
Ensure brevity in your answer.  -9.69. What is the difference between the Imports(as % of merchandise exports) of Pacific island small states in 2003 and the Imports(as % of merchandise exports) of Nicaragua in 2004?
Offer a very short reply. -7.25. What is the difference between the Imports(as % of merchandise exports) of Italy in 2003 and the Imports(as % of merchandise exports) of Korea (Republic) in 2004?
Your response must be concise. -13.27. What is the difference between the Imports(as % of merchandise exports) in Italy in 2003 and the Imports(as % of merchandise exports) in Nicaragua in 2004?
Offer a very short reply. -10.83. What is the difference between the Imports(as % of merchandise exports) in Korea (Republic) in 2003 and the Imports(as % of merchandise exports) in Nicaragua in 2004?
Make the answer very short. 1.79. What is the difference between the Imports(as % of merchandise exports) of Pacific island small states in 2003 and the Imports(as % of merchandise exports) of Italy in 2005?
Make the answer very short. 0.7. What is the difference between the Imports(as % of merchandise exports) of Pacific island small states in 2003 and the Imports(as % of merchandise exports) of Korea (Republic) in 2005?
Your response must be concise. -12.89. What is the difference between the Imports(as % of merchandise exports) of Pacific island small states in 2003 and the Imports(as % of merchandise exports) of Nicaragua in 2005?
Provide a short and direct response. -5.52. What is the difference between the Imports(as % of merchandise exports) in Italy in 2003 and the Imports(as % of merchandise exports) in Korea (Republic) in 2005?
Offer a very short reply. -16.47. What is the difference between the Imports(as % of merchandise exports) in Italy in 2003 and the Imports(as % of merchandise exports) in Nicaragua in 2005?
Your answer should be very brief. -9.1. What is the difference between the Imports(as % of merchandise exports) in Korea (Republic) in 2003 and the Imports(as % of merchandise exports) in Nicaragua in 2005?
Keep it short and to the point. 3.52. What is the difference between the Imports(as % of merchandise exports) of Pacific island small states in 2004 and the Imports(as % of merchandise exports) of Italy in 2005?
Your answer should be very brief. 2.71. What is the difference between the Imports(as % of merchandise exports) of Pacific island small states in 2004 and the Imports(as % of merchandise exports) of Korea (Republic) in 2005?
Ensure brevity in your answer.  -10.88. What is the difference between the Imports(as % of merchandise exports) of Pacific island small states in 2004 and the Imports(as % of merchandise exports) of Nicaragua in 2005?
Make the answer very short. -3.51. What is the difference between the Imports(as % of merchandise exports) in Italy in 2004 and the Imports(as % of merchandise exports) in Korea (Republic) in 2005?
Your answer should be very brief. -15.96. What is the difference between the Imports(as % of merchandise exports) of Italy in 2004 and the Imports(as % of merchandise exports) of Nicaragua in 2005?
Make the answer very short. -8.59. What is the difference between the Imports(as % of merchandise exports) in Korea (Republic) in 2004 and the Imports(as % of merchandise exports) in Nicaragua in 2005?
Make the answer very short. 4.17. What is the average Imports(as % of merchandise exports) in Pacific island small states per year?
Give a very brief answer. 14.05. What is the average Imports(as % of merchandise exports) in Italy per year?
Keep it short and to the point. 9.86. What is the average Imports(as % of merchandise exports) of Korea (Republic) per year?
Offer a terse response. 21.62. What is the average Imports(as % of merchandise exports) of Nicaragua per year?
Offer a very short reply. 17.21. In the year 1990, what is the difference between the Imports(as % of merchandise exports) of Pacific island small states and Imports(as % of merchandise exports) of Italy?
Your answer should be compact. 3. In the year 1990, what is the difference between the Imports(as % of merchandise exports) of Pacific island small states and Imports(as % of merchandise exports) of Korea (Republic)?
Provide a succinct answer. -2.16. In the year 1990, what is the difference between the Imports(as % of merchandise exports) in Pacific island small states and Imports(as % of merchandise exports) in Nicaragua?
Keep it short and to the point. -5.37. In the year 1990, what is the difference between the Imports(as % of merchandise exports) in Italy and Imports(as % of merchandise exports) in Korea (Republic)?
Provide a succinct answer. -5.16. In the year 1990, what is the difference between the Imports(as % of merchandise exports) of Italy and Imports(as % of merchandise exports) of Nicaragua?
Your answer should be compact. -8.37. In the year 1990, what is the difference between the Imports(as % of merchandise exports) in Korea (Republic) and Imports(as % of merchandise exports) in Nicaragua?
Provide a succinct answer. -3.21. In the year 1993, what is the difference between the Imports(as % of merchandise exports) in Pacific island small states and Imports(as % of merchandise exports) in Italy?
Make the answer very short. 3.55. In the year 1993, what is the difference between the Imports(as % of merchandise exports) in Pacific island small states and Imports(as % of merchandise exports) in Korea (Republic)?
Provide a succinct answer. -5.01. In the year 1993, what is the difference between the Imports(as % of merchandise exports) in Pacific island small states and Imports(as % of merchandise exports) in Nicaragua?
Provide a succinct answer. -0.89. In the year 1993, what is the difference between the Imports(as % of merchandise exports) in Italy and Imports(as % of merchandise exports) in Korea (Republic)?
Provide a succinct answer. -8.56. In the year 1993, what is the difference between the Imports(as % of merchandise exports) of Italy and Imports(as % of merchandise exports) of Nicaragua?
Provide a succinct answer. -4.44. In the year 1993, what is the difference between the Imports(as % of merchandise exports) in Korea (Republic) and Imports(as % of merchandise exports) in Nicaragua?
Your response must be concise. 4.11. In the year 2000, what is the difference between the Imports(as % of merchandise exports) in Pacific island small states and Imports(as % of merchandise exports) in Italy?
Your answer should be compact. -1.79. In the year 2000, what is the difference between the Imports(as % of merchandise exports) in Pacific island small states and Imports(as % of merchandise exports) in Korea (Republic)?
Provide a short and direct response. -15.87. In the year 2000, what is the difference between the Imports(as % of merchandise exports) of Pacific island small states and Imports(as % of merchandise exports) of Nicaragua?
Offer a very short reply. -9.81. In the year 2000, what is the difference between the Imports(as % of merchandise exports) of Italy and Imports(as % of merchandise exports) of Korea (Republic)?
Keep it short and to the point. -14.08. In the year 2000, what is the difference between the Imports(as % of merchandise exports) of Italy and Imports(as % of merchandise exports) of Nicaragua?
Give a very brief answer. -8.02. In the year 2000, what is the difference between the Imports(as % of merchandise exports) in Korea (Republic) and Imports(as % of merchandise exports) in Nicaragua?
Your answer should be very brief. 6.06. In the year 2001, what is the difference between the Imports(as % of merchandise exports) in Pacific island small states and Imports(as % of merchandise exports) in Italy?
Provide a short and direct response. 2.09. In the year 2001, what is the difference between the Imports(as % of merchandise exports) in Pacific island small states and Imports(as % of merchandise exports) in Korea (Republic)?
Your answer should be very brief. -12.84. In the year 2001, what is the difference between the Imports(as % of merchandise exports) of Pacific island small states and Imports(as % of merchandise exports) of Nicaragua?
Your answer should be very brief. -5.97. In the year 2001, what is the difference between the Imports(as % of merchandise exports) of Italy and Imports(as % of merchandise exports) of Korea (Republic)?
Provide a succinct answer. -14.93. In the year 2001, what is the difference between the Imports(as % of merchandise exports) in Italy and Imports(as % of merchandise exports) in Nicaragua?
Your answer should be compact. -8.06. In the year 2001, what is the difference between the Imports(as % of merchandise exports) of Korea (Republic) and Imports(as % of merchandise exports) of Nicaragua?
Offer a terse response. 6.87. In the year 2002, what is the difference between the Imports(as % of merchandise exports) of Pacific island small states and Imports(as % of merchandise exports) of Italy?
Make the answer very short. 3.58. In the year 2002, what is the difference between the Imports(as % of merchandise exports) in Pacific island small states and Imports(as % of merchandise exports) in Korea (Republic)?
Make the answer very short. -8.76. In the year 2002, what is the difference between the Imports(as % of merchandise exports) of Pacific island small states and Imports(as % of merchandise exports) of Nicaragua?
Your response must be concise. -0.49. In the year 2002, what is the difference between the Imports(as % of merchandise exports) in Italy and Imports(as % of merchandise exports) in Korea (Republic)?
Keep it short and to the point. -12.34. In the year 2002, what is the difference between the Imports(as % of merchandise exports) in Italy and Imports(as % of merchandise exports) in Nicaragua?
Give a very brief answer. -4.07. In the year 2002, what is the difference between the Imports(as % of merchandise exports) in Korea (Republic) and Imports(as % of merchandise exports) in Nicaragua?
Offer a terse response. 8.27. In the year 2003, what is the difference between the Imports(as % of merchandise exports) in Pacific island small states and Imports(as % of merchandise exports) in Italy?
Provide a short and direct response. 3.58. In the year 2003, what is the difference between the Imports(as % of merchandise exports) in Pacific island small states and Imports(as % of merchandise exports) in Korea (Republic)?
Make the answer very short. -9.04. In the year 2003, what is the difference between the Imports(as % of merchandise exports) of Pacific island small states and Imports(as % of merchandise exports) of Nicaragua?
Provide a succinct answer. -5.67. In the year 2003, what is the difference between the Imports(as % of merchandise exports) in Italy and Imports(as % of merchandise exports) in Korea (Republic)?
Make the answer very short. -12.62. In the year 2003, what is the difference between the Imports(as % of merchandise exports) of Italy and Imports(as % of merchandise exports) of Nicaragua?
Offer a very short reply. -9.25. In the year 2003, what is the difference between the Imports(as % of merchandise exports) of Korea (Republic) and Imports(as % of merchandise exports) of Nicaragua?
Make the answer very short. 3.37. In the year 2004, what is the difference between the Imports(as % of merchandise exports) in Pacific island small states and Imports(as % of merchandise exports) in Italy?
Provide a succinct answer. 5.08. In the year 2004, what is the difference between the Imports(as % of merchandise exports) in Pacific island small states and Imports(as % of merchandise exports) in Korea (Republic)?
Your answer should be very brief. -7.68. In the year 2004, what is the difference between the Imports(as % of merchandise exports) of Pacific island small states and Imports(as % of merchandise exports) of Nicaragua?
Your response must be concise. -5.24. In the year 2004, what is the difference between the Imports(as % of merchandise exports) in Italy and Imports(as % of merchandise exports) in Korea (Republic)?
Give a very brief answer. -12.76. In the year 2004, what is the difference between the Imports(as % of merchandise exports) of Italy and Imports(as % of merchandise exports) of Nicaragua?
Provide a short and direct response. -10.32. In the year 2004, what is the difference between the Imports(as % of merchandise exports) in Korea (Republic) and Imports(as % of merchandise exports) in Nicaragua?
Your answer should be very brief. 2.44. In the year 2005, what is the difference between the Imports(as % of merchandise exports) in Pacific island small states and Imports(as % of merchandise exports) in Italy?
Your response must be concise. 14.4. In the year 2005, what is the difference between the Imports(as % of merchandise exports) of Pacific island small states and Imports(as % of merchandise exports) of Korea (Republic)?
Offer a very short reply. 0.82. In the year 2005, what is the difference between the Imports(as % of merchandise exports) of Pacific island small states and Imports(as % of merchandise exports) of Nicaragua?
Offer a very short reply. 8.19. In the year 2005, what is the difference between the Imports(as % of merchandise exports) of Italy and Imports(as % of merchandise exports) of Korea (Republic)?
Your answer should be compact. -13.59. In the year 2005, what is the difference between the Imports(as % of merchandise exports) in Italy and Imports(as % of merchandise exports) in Nicaragua?
Ensure brevity in your answer.  -6.22. In the year 2005, what is the difference between the Imports(as % of merchandise exports) of Korea (Republic) and Imports(as % of merchandise exports) of Nicaragua?
Make the answer very short. 7.37. What is the ratio of the Imports(as % of merchandise exports) of Pacific island small states in 1990 to that in 1993?
Offer a terse response. 1.05. What is the ratio of the Imports(as % of merchandise exports) of Italy in 1990 to that in 1993?
Provide a succinct answer. 1.12. What is the ratio of the Imports(as % of merchandise exports) in Korea (Republic) in 1990 to that in 1993?
Your answer should be compact. 0.88. What is the ratio of the Imports(as % of merchandise exports) of Nicaragua in 1990 to that in 1993?
Provide a short and direct response. 1.36. What is the ratio of the Imports(as % of merchandise exports) of Pacific island small states in 1990 to that in 2000?
Your answer should be compact. 1.7. What is the ratio of the Imports(as % of merchandise exports) in Italy in 1990 to that in 2000?
Make the answer very short. 1.09. What is the ratio of the Imports(as % of merchandise exports) of Korea (Republic) in 1990 to that in 2000?
Provide a short and direct response. 0.66. What is the ratio of the Imports(as % of merchandise exports) of Nicaragua in 1990 to that in 2000?
Offer a terse response. 1.07. What is the ratio of the Imports(as % of merchandise exports) in Pacific island small states in 1990 to that in 2001?
Make the answer very short. 1.2. What is the ratio of the Imports(as % of merchandise exports) in Italy in 1990 to that in 2001?
Provide a succinct answer. 1.15. What is the ratio of the Imports(as % of merchandise exports) of Korea (Republic) in 1990 to that in 2001?
Offer a terse response. 0.65. What is the ratio of the Imports(as % of merchandise exports) in Nicaragua in 1990 to that in 2001?
Your answer should be compact. 1.1. What is the ratio of the Imports(as % of merchandise exports) of Pacific island small states in 1990 to that in 2002?
Your answer should be very brief. 1.08. What is the ratio of the Imports(as % of merchandise exports) of Italy in 1990 to that in 2002?
Your answer should be compact. 1.18. What is the ratio of the Imports(as % of merchandise exports) of Korea (Republic) in 1990 to that in 2002?
Provide a succinct answer. 0.74. What is the ratio of the Imports(as % of merchandise exports) of Nicaragua in 1990 to that in 2002?
Your response must be concise. 1.45. What is the ratio of the Imports(as % of merchandise exports) of Pacific island small states in 1990 to that in 2003?
Your answer should be very brief. 1.08. What is the ratio of the Imports(as % of merchandise exports) of Italy in 1990 to that in 2003?
Give a very brief answer. 1.17. What is the ratio of the Imports(as % of merchandise exports) of Korea (Republic) in 1990 to that in 2003?
Offer a very short reply. 0.73. What is the ratio of the Imports(as % of merchandise exports) of Nicaragua in 1990 to that in 2003?
Ensure brevity in your answer.  1.04. What is the ratio of the Imports(as % of merchandise exports) of Pacific island small states in 1990 to that in 2004?
Your response must be concise. 0.93. What is the ratio of the Imports(as % of merchandise exports) in Korea (Republic) in 1990 to that in 2004?
Provide a short and direct response. 0.71. What is the ratio of the Imports(as % of merchandise exports) of Nicaragua in 1990 to that in 2004?
Provide a short and direct response. 0.96. What is the ratio of the Imports(as % of merchandise exports) in Pacific island small states in 1990 to that in 2005?
Give a very brief answer. 0.52. What is the ratio of the Imports(as % of merchandise exports) in Italy in 1990 to that in 2005?
Give a very brief answer. 0.89. What is the ratio of the Imports(as % of merchandise exports) of Korea (Republic) in 1990 to that in 2005?
Offer a terse response. 0.62. What is the ratio of the Imports(as % of merchandise exports) in Nicaragua in 1990 to that in 2005?
Make the answer very short. 1.05. What is the ratio of the Imports(as % of merchandise exports) in Pacific island small states in 1993 to that in 2000?
Your response must be concise. 1.63. What is the ratio of the Imports(as % of merchandise exports) of Italy in 1993 to that in 2000?
Offer a very short reply. 0.97. What is the ratio of the Imports(as % of merchandise exports) of Korea (Republic) in 1993 to that in 2000?
Ensure brevity in your answer.  0.76. What is the ratio of the Imports(as % of merchandise exports) in Nicaragua in 1993 to that in 2000?
Ensure brevity in your answer.  0.78. What is the ratio of the Imports(as % of merchandise exports) of Pacific island small states in 1993 to that in 2001?
Your answer should be compact. 1.15. What is the ratio of the Imports(as % of merchandise exports) in Italy in 1993 to that in 2001?
Your answer should be compact. 1.02. What is the ratio of the Imports(as % of merchandise exports) in Korea (Republic) in 1993 to that in 2001?
Make the answer very short. 0.75. What is the ratio of the Imports(as % of merchandise exports) of Nicaragua in 1993 to that in 2001?
Your response must be concise. 0.8. What is the ratio of the Imports(as % of merchandise exports) in Pacific island small states in 1993 to that in 2002?
Give a very brief answer. 1.03. What is the ratio of the Imports(as % of merchandise exports) of Italy in 1993 to that in 2002?
Your answer should be very brief. 1.05. What is the ratio of the Imports(as % of merchandise exports) of Korea (Republic) in 1993 to that in 2002?
Provide a succinct answer. 0.84. What is the ratio of the Imports(as % of merchandise exports) in Nicaragua in 1993 to that in 2002?
Keep it short and to the point. 1.06. What is the ratio of the Imports(as % of merchandise exports) in Pacific island small states in 1993 to that in 2003?
Offer a terse response. 1.03. What is the ratio of the Imports(as % of merchandise exports) of Italy in 1993 to that in 2003?
Ensure brevity in your answer.  1.05. What is the ratio of the Imports(as % of merchandise exports) of Korea (Republic) in 1993 to that in 2003?
Ensure brevity in your answer.  0.83. What is the ratio of the Imports(as % of merchandise exports) in Nicaragua in 1993 to that in 2003?
Your response must be concise. 0.76. What is the ratio of the Imports(as % of merchandise exports) of Pacific island small states in 1993 to that in 2004?
Ensure brevity in your answer.  0.89. What is the ratio of the Imports(as % of merchandise exports) of Korea (Republic) in 1993 to that in 2004?
Provide a short and direct response. 0.81. What is the ratio of the Imports(as % of merchandise exports) in Nicaragua in 1993 to that in 2004?
Ensure brevity in your answer.  0.7. What is the ratio of the Imports(as % of merchandise exports) in Pacific island small states in 1993 to that in 2005?
Provide a short and direct response. 0.49. What is the ratio of the Imports(as % of merchandise exports) in Italy in 1993 to that in 2005?
Provide a succinct answer. 0.79. What is the ratio of the Imports(as % of merchandise exports) in Korea (Republic) in 1993 to that in 2005?
Your answer should be very brief. 0.71. What is the ratio of the Imports(as % of merchandise exports) of Nicaragua in 1993 to that in 2005?
Offer a very short reply. 0.77. What is the ratio of the Imports(as % of merchandise exports) in Pacific island small states in 2000 to that in 2001?
Make the answer very short. 0.7. What is the ratio of the Imports(as % of merchandise exports) of Italy in 2000 to that in 2001?
Your answer should be compact. 1.05. What is the ratio of the Imports(as % of merchandise exports) in Korea (Republic) in 2000 to that in 2001?
Your answer should be very brief. 0.99. What is the ratio of the Imports(as % of merchandise exports) in Nicaragua in 2000 to that in 2001?
Your answer should be very brief. 1.03. What is the ratio of the Imports(as % of merchandise exports) of Pacific island small states in 2000 to that in 2002?
Your response must be concise. 0.64. What is the ratio of the Imports(as % of merchandise exports) in Italy in 2000 to that in 2002?
Your answer should be compact. 1.09. What is the ratio of the Imports(as % of merchandise exports) in Korea (Republic) in 2000 to that in 2002?
Provide a short and direct response. 1.12. What is the ratio of the Imports(as % of merchandise exports) of Nicaragua in 2000 to that in 2002?
Offer a very short reply. 1.36. What is the ratio of the Imports(as % of merchandise exports) of Pacific island small states in 2000 to that in 2003?
Give a very brief answer. 0.63. What is the ratio of the Imports(as % of merchandise exports) in Italy in 2000 to that in 2003?
Provide a short and direct response. 1.08. What is the ratio of the Imports(as % of merchandise exports) in Korea (Republic) in 2000 to that in 2003?
Make the answer very short. 1.1. What is the ratio of the Imports(as % of merchandise exports) in Nicaragua in 2000 to that in 2003?
Give a very brief answer. 0.97. What is the ratio of the Imports(as % of merchandise exports) in Pacific island small states in 2000 to that in 2004?
Offer a very short reply. 0.55. What is the ratio of the Imports(as % of merchandise exports) in Italy in 2000 to that in 2004?
Your answer should be very brief. 1.02. What is the ratio of the Imports(as % of merchandise exports) of Korea (Republic) in 2000 to that in 2004?
Your answer should be compact. 1.07. What is the ratio of the Imports(as % of merchandise exports) of Nicaragua in 2000 to that in 2004?
Offer a terse response. 0.9. What is the ratio of the Imports(as % of merchandise exports) in Pacific island small states in 2000 to that in 2005?
Keep it short and to the point. 0.3. What is the ratio of the Imports(as % of merchandise exports) of Italy in 2000 to that in 2005?
Offer a terse response. 0.82. What is the ratio of the Imports(as % of merchandise exports) in Korea (Republic) in 2000 to that in 2005?
Give a very brief answer. 0.94. What is the ratio of the Imports(as % of merchandise exports) in Nicaragua in 2000 to that in 2005?
Provide a short and direct response. 0.98. What is the ratio of the Imports(as % of merchandise exports) of Pacific island small states in 2001 to that in 2002?
Your answer should be compact. 0.9. What is the ratio of the Imports(as % of merchandise exports) of Italy in 2001 to that in 2002?
Provide a succinct answer. 1.03. What is the ratio of the Imports(as % of merchandise exports) of Korea (Republic) in 2001 to that in 2002?
Your answer should be compact. 1.13. What is the ratio of the Imports(as % of merchandise exports) of Nicaragua in 2001 to that in 2002?
Offer a very short reply. 1.33. What is the ratio of the Imports(as % of merchandise exports) in Pacific island small states in 2001 to that in 2003?
Provide a succinct answer. 0.9. What is the ratio of the Imports(as % of merchandise exports) of Italy in 2001 to that in 2003?
Ensure brevity in your answer.  1.02. What is the ratio of the Imports(as % of merchandise exports) of Korea (Republic) in 2001 to that in 2003?
Your answer should be very brief. 1.12. What is the ratio of the Imports(as % of merchandise exports) in Nicaragua in 2001 to that in 2003?
Give a very brief answer. 0.95. What is the ratio of the Imports(as % of merchandise exports) of Pacific island small states in 2001 to that in 2004?
Offer a terse response. 0.78. What is the ratio of the Imports(as % of merchandise exports) in Italy in 2001 to that in 2004?
Provide a succinct answer. 0.97. What is the ratio of the Imports(as % of merchandise exports) in Korea (Republic) in 2001 to that in 2004?
Your answer should be compact. 1.08. What is the ratio of the Imports(as % of merchandise exports) of Nicaragua in 2001 to that in 2004?
Keep it short and to the point. 0.87. What is the ratio of the Imports(as % of merchandise exports) in Pacific island small states in 2001 to that in 2005?
Offer a terse response. 0.43. What is the ratio of the Imports(as % of merchandise exports) of Italy in 2001 to that in 2005?
Your response must be concise. 0.78. What is the ratio of the Imports(as % of merchandise exports) of Korea (Republic) in 2001 to that in 2005?
Your answer should be compact. 0.95. What is the ratio of the Imports(as % of merchandise exports) of Nicaragua in 2001 to that in 2005?
Ensure brevity in your answer.  0.96. What is the ratio of the Imports(as % of merchandise exports) in Italy in 2002 to that in 2003?
Offer a very short reply. 1. What is the ratio of the Imports(as % of merchandise exports) in Nicaragua in 2002 to that in 2003?
Offer a very short reply. 0.71. What is the ratio of the Imports(as % of merchandise exports) of Pacific island small states in 2002 to that in 2004?
Your response must be concise. 0.86. What is the ratio of the Imports(as % of merchandise exports) of Italy in 2002 to that in 2004?
Make the answer very short. 0.94. What is the ratio of the Imports(as % of merchandise exports) of Korea (Republic) in 2002 to that in 2004?
Your answer should be compact. 0.96. What is the ratio of the Imports(as % of merchandise exports) in Nicaragua in 2002 to that in 2004?
Ensure brevity in your answer.  0.66. What is the ratio of the Imports(as % of merchandise exports) of Pacific island small states in 2002 to that in 2005?
Give a very brief answer. 0.48. What is the ratio of the Imports(as % of merchandise exports) in Italy in 2002 to that in 2005?
Offer a very short reply. 0.76. What is the ratio of the Imports(as % of merchandise exports) of Korea (Republic) in 2002 to that in 2005?
Your answer should be very brief. 0.84. What is the ratio of the Imports(as % of merchandise exports) of Nicaragua in 2002 to that in 2005?
Offer a terse response. 0.72. What is the ratio of the Imports(as % of merchandise exports) in Pacific island small states in 2003 to that in 2004?
Offer a very short reply. 0.86. What is the ratio of the Imports(as % of merchandise exports) of Italy in 2003 to that in 2004?
Provide a short and direct response. 0.95. What is the ratio of the Imports(as % of merchandise exports) of Nicaragua in 2003 to that in 2004?
Your answer should be very brief. 0.92. What is the ratio of the Imports(as % of merchandise exports) in Pacific island small states in 2003 to that in 2005?
Give a very brief answer. 0.48. What is the ratio of the Imports(as % of merchandise exports) in Italy in 2003 to that in 2005?
Keep it short and to the point. 0.76. What is the ratio of the Imports(as % of merchandise exports) in Korea (Republic) in 2003 to that in 2005?
Provide a succinct answer. 0.85. What is the ratio of the Imports(as % of merchandise exports) of Nicaragua in 2003 to that in 2005?
Your response must be concise. 1.01. What is the ratio of the Imports(as % of merchandise exports) in Pacific island small states in 2004 to that in 2005?
Your answer should be very brief. 0.56. What is the ratio of the Imports(as % of merchandise exports) of Italy in 2004 to that in 2005?
Provide a short and direct response. 0.8. What is the ratio of the Imports(as % of merchandise exports) of Korea (Republic) in 2004 to that in 2005?
Ensure brevity in your answer.  0.87. What is the ratio of the Imports(as % of merchandise exports) of Nicaragua in 2004 to that in 2005?
Offer a terse response. 1.1. What is the difference between the highest and the second highest Imports(as % of merchandise exports) in Pacific island small states?
Your response must be concise. 11.69. What is the difference between the highest and the second highest Imports(as % of merchandise exports) of Italy?
Ensure brevity in your answer.  1.31. What is the difference between the highest and the second highest Imports(as % of merchandise exports) in Korea (Republic)?
Provide a succinct answer. 1.31. What is the difference between the highest and the second highest Imports(as % of merchandise exports) of Nicaragua?
Your answer should be very brief. 0.89. What is the difference between the highest and the lowest Imports(as % of merchandise exports) of Pacific island small states?
Give a very brief answer. 18.34. What is the difference between the highest and the lowest Imports(as % of merchandise exports) of Italy?
Your answer should be compact. 2.93. What is the difference between the highest and the lowest Imports(as % of merchandise exports) of Korea (Republic)?
Your answer should be very brief. 9.73. What is the difference between the highest and the lowest Imports(as % of merchandise exports) of Nicaragua?
Provide a succinct answer. 6.81. 